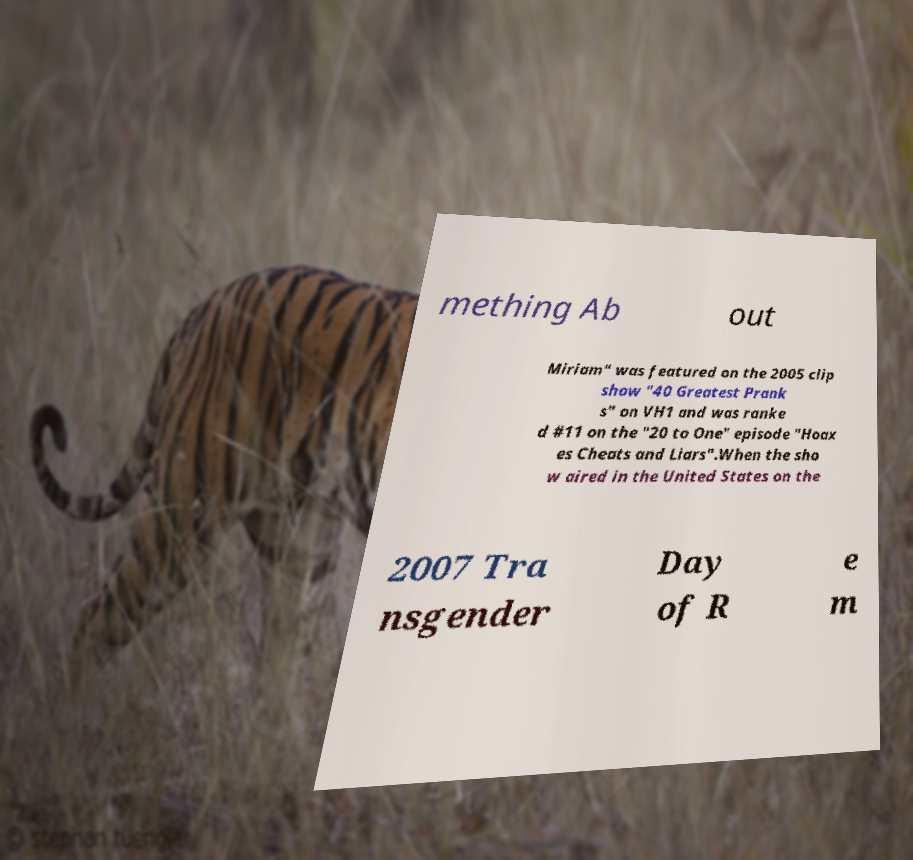I need the written content from this picture converted into text. Can you do that? mething Ab out Miriam" was featured on the 2005 clip show "40 Greatest Prank s" on VH1 and was ranke d #11 on the "20 to One" episode "Hoax es Cheats and Liars".When the sho w aired in the United States on the 2007 Tra nsgender Day of R e m 